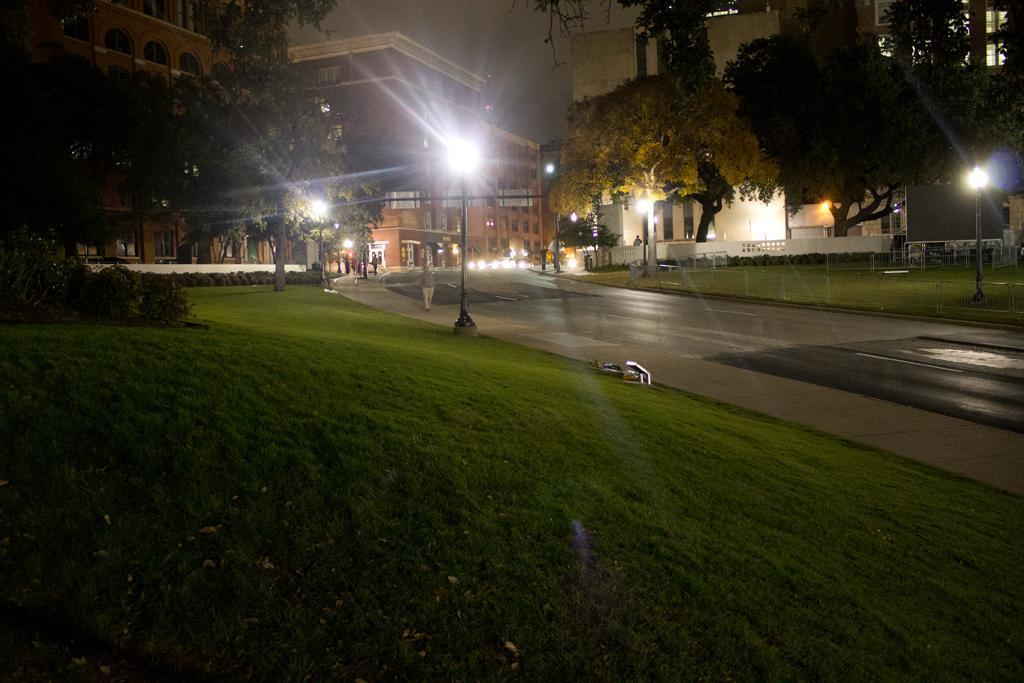What type of vegetation can be seen in the image? There is grass in the image. What type of artificial lighting is present in the image? There are street lights in the image. What type of pathway is visible in the image? There is a road in the image. What type of barrier is present in the image? There is a fence in the image. What type of natural structures are present in the image? There are trees in the image. What type of man-made structures are present in the image? There are buildings in the image. What other objects can be seen on the ground in the image? There are other objects on the ground in the image. What can be seen in the background of the image? The sky is visible in the background of the image. What is the value of the mom's smile in the image? There is no mom or smile present in the image. What does the grass smell like in the image? The image does not provide information about the smell of the grass. 